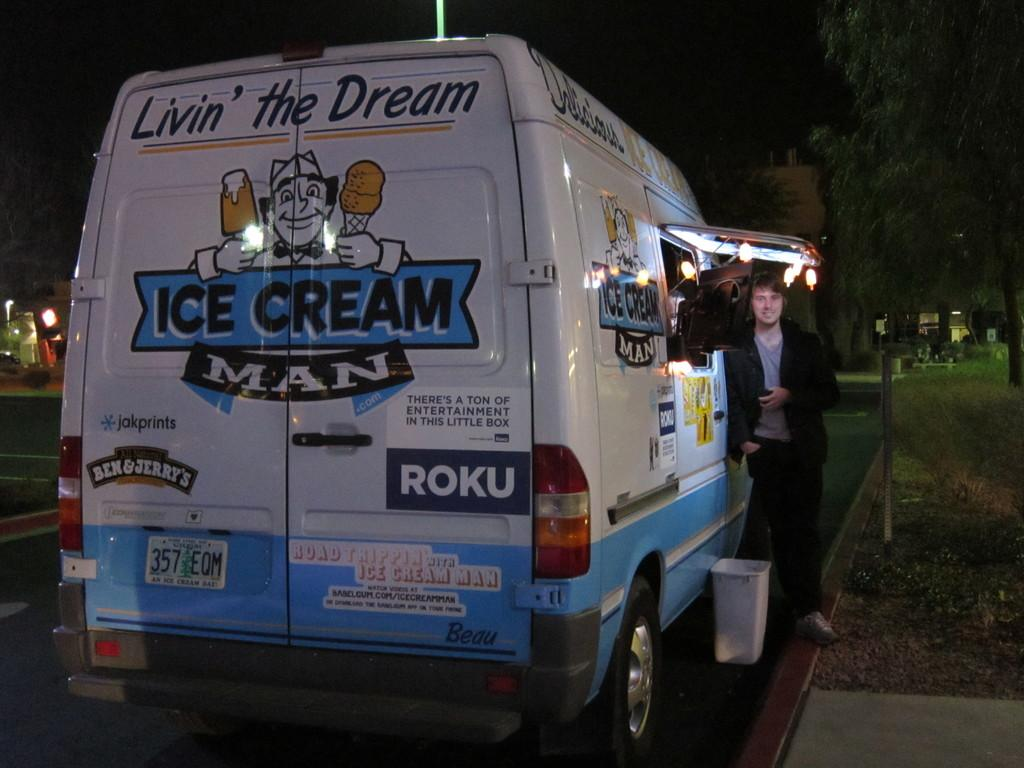<image>
Write a terse but informative summary of the picture. the word Roku is on the back of the van 